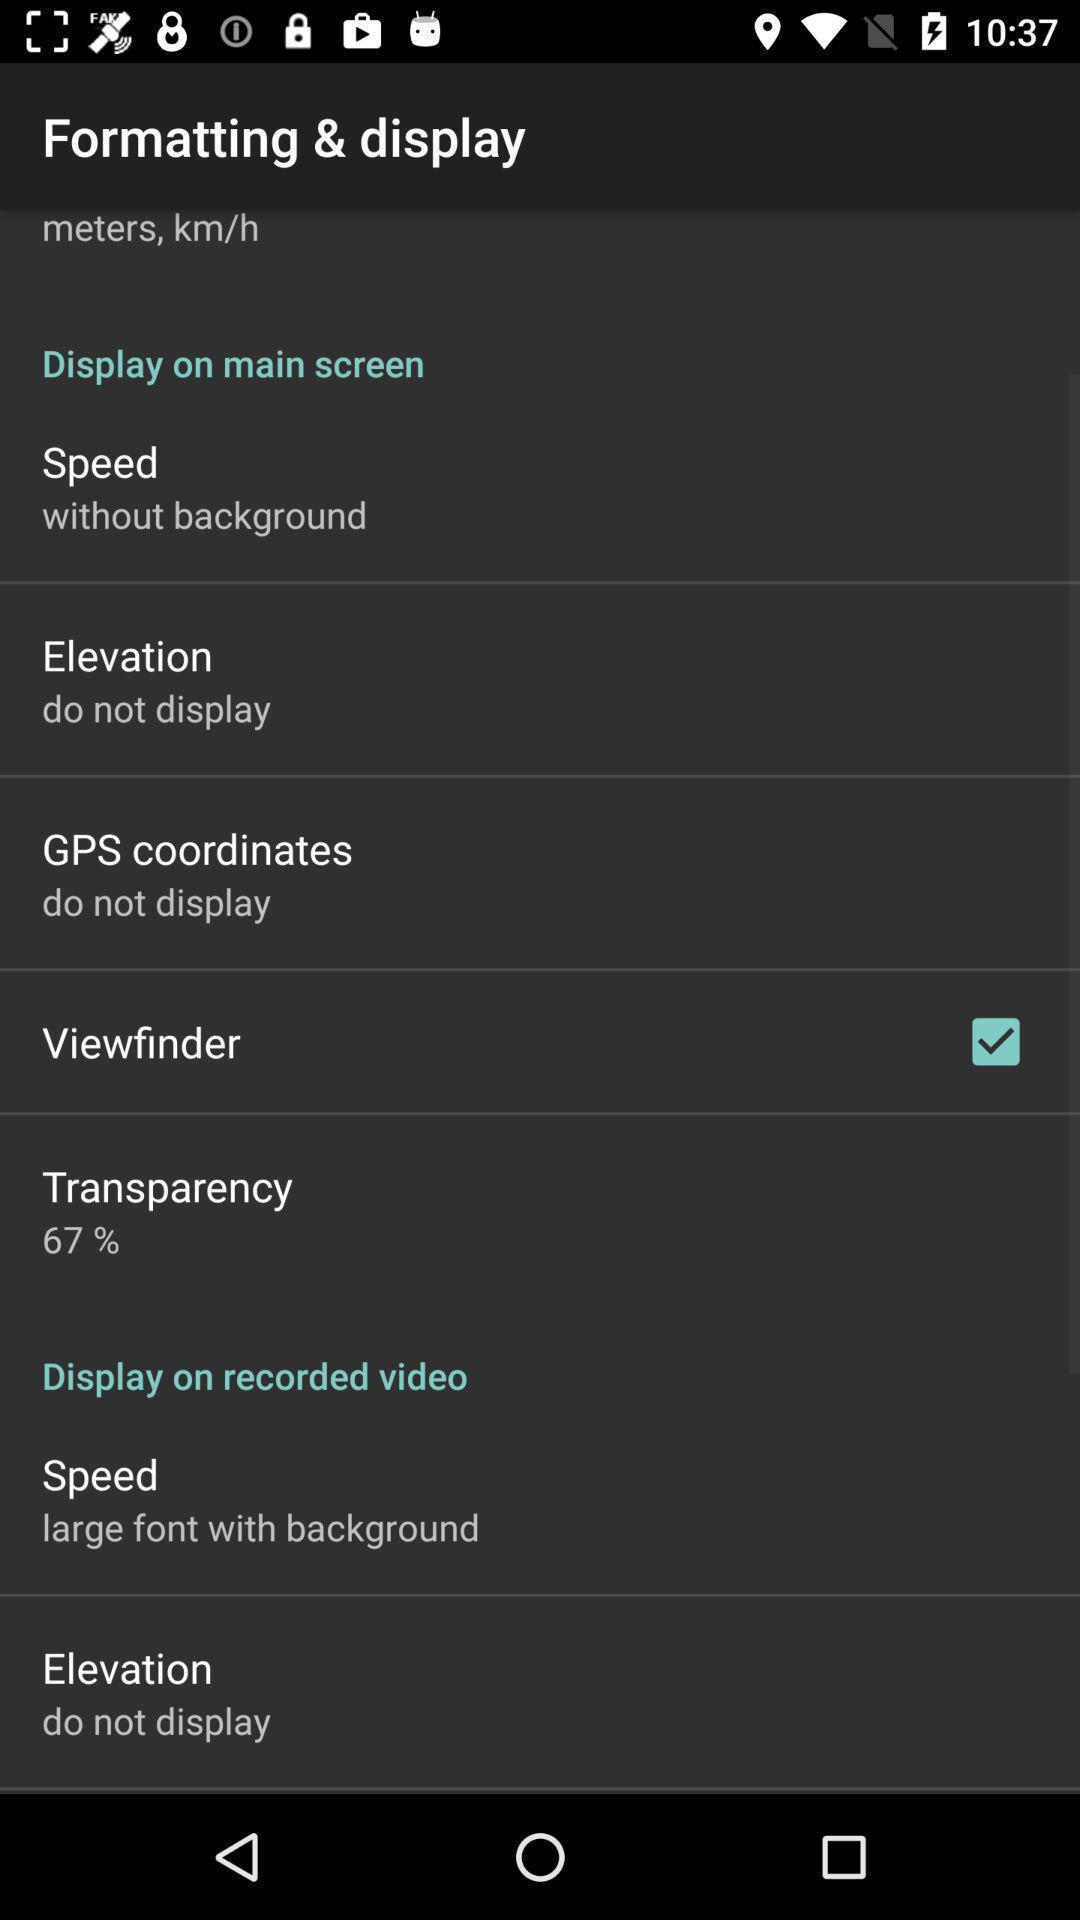Summarize the information in this screenshot. Settings page. 